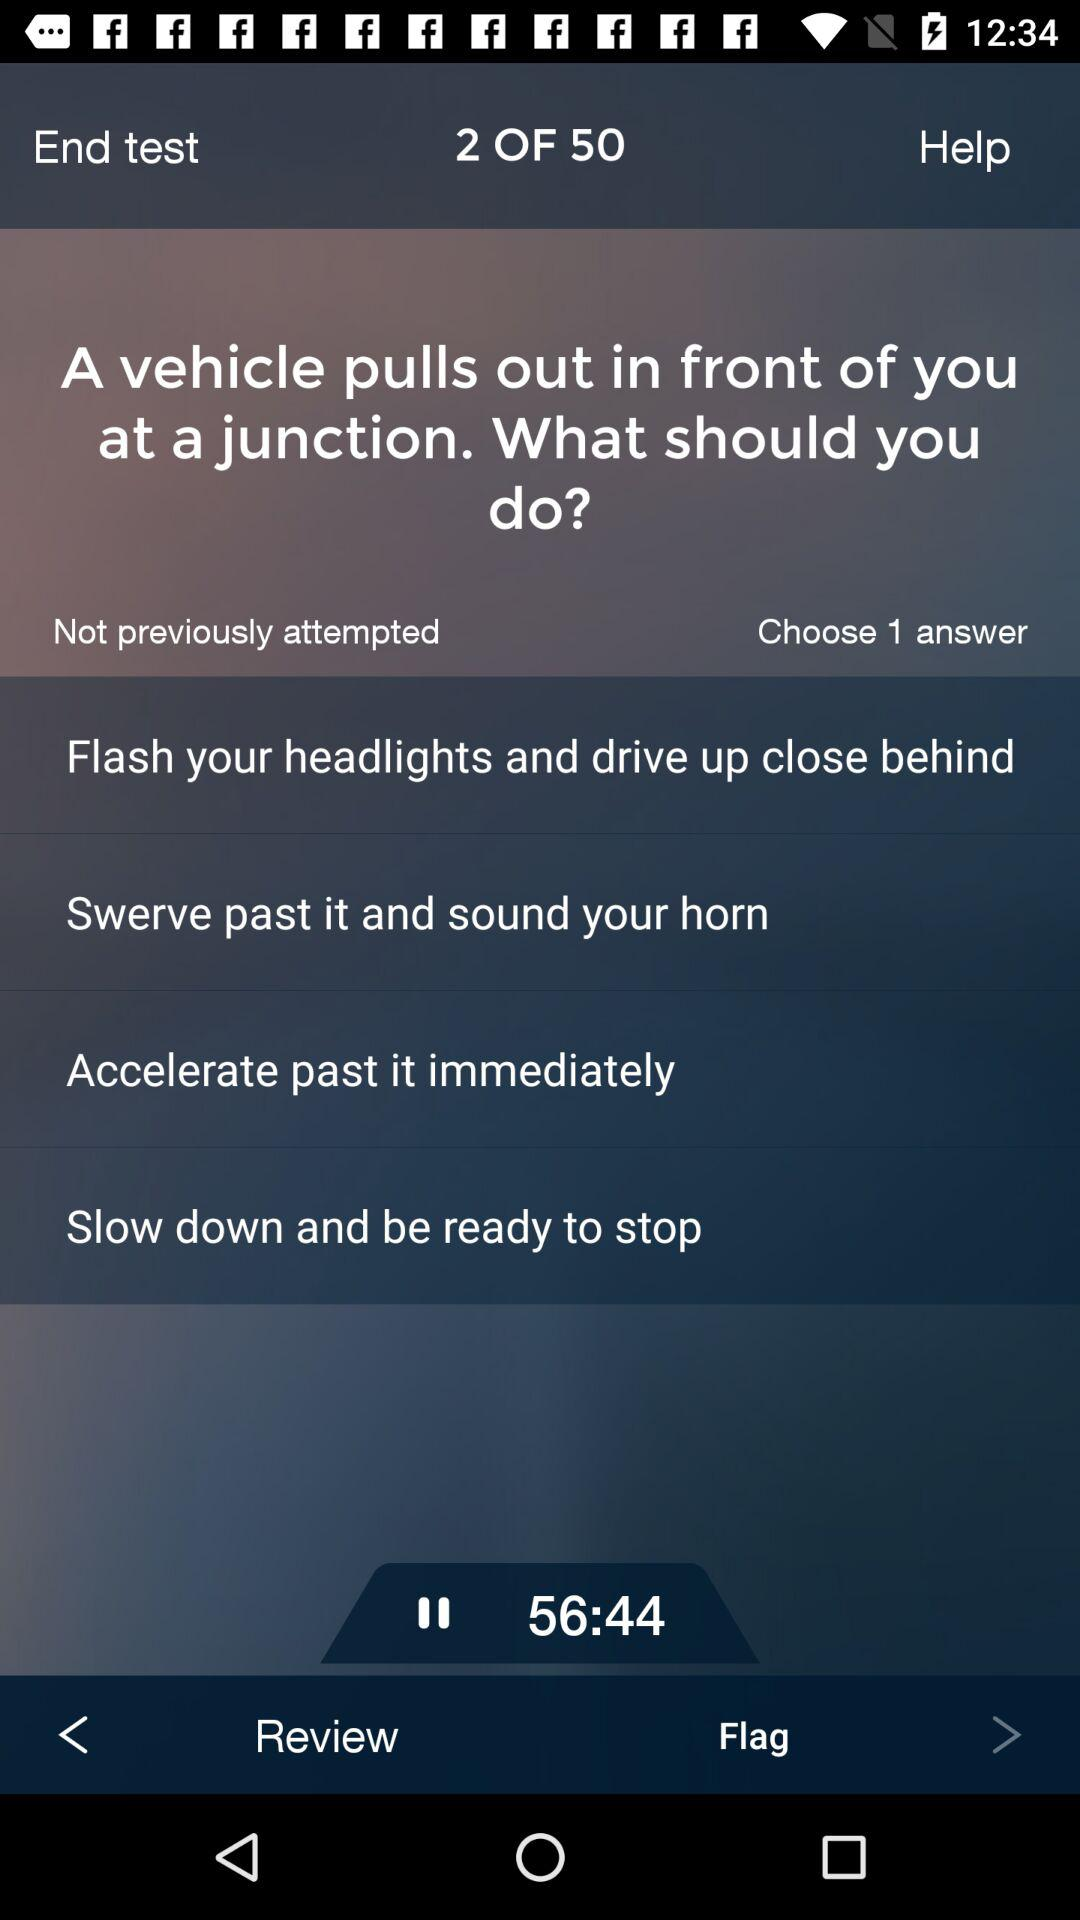How many questions in total are there? There are 50 questions in total. 